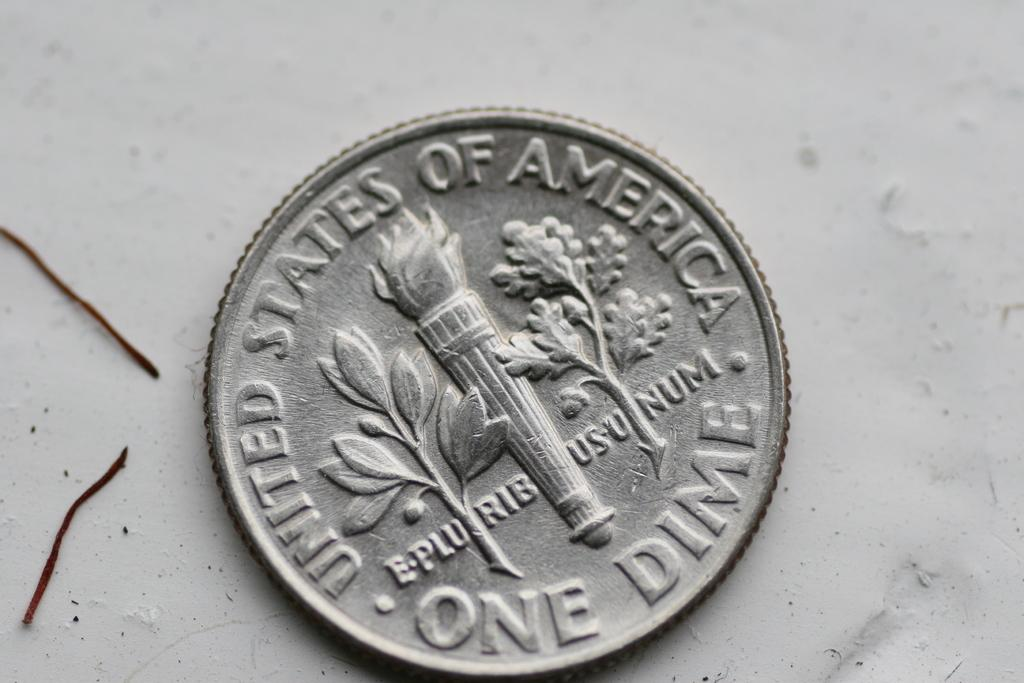Provide a one-sentence caption for the provided image. a close up of a One Dime coin on a marble surface. 